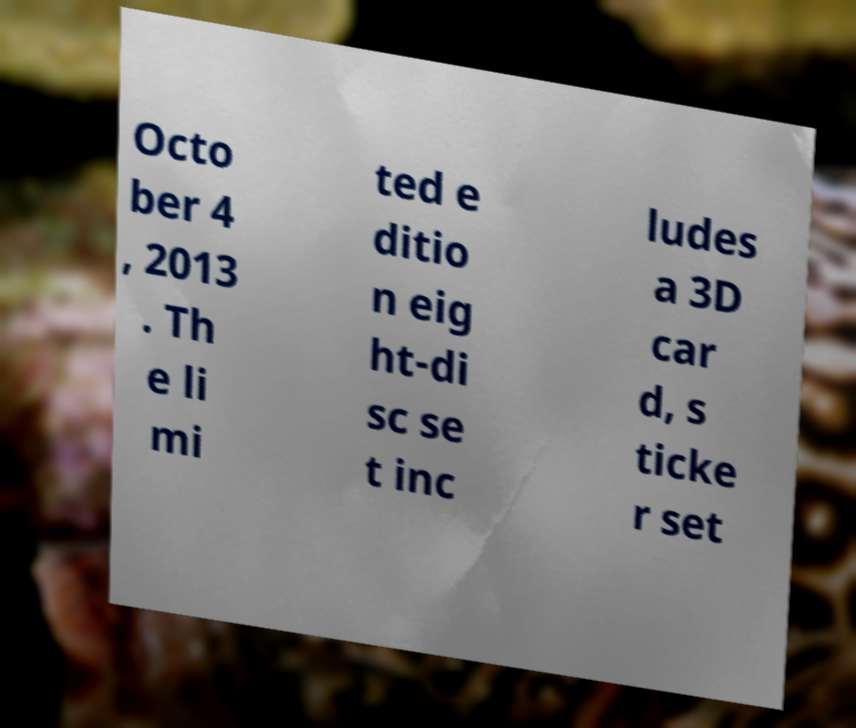Could you extract and type out the text from this image? Octo ber 4 , 2013 . Th e li mi ted e ditio n eig ht-di sc se t inc ludes a 3D car d, s ticke r set 